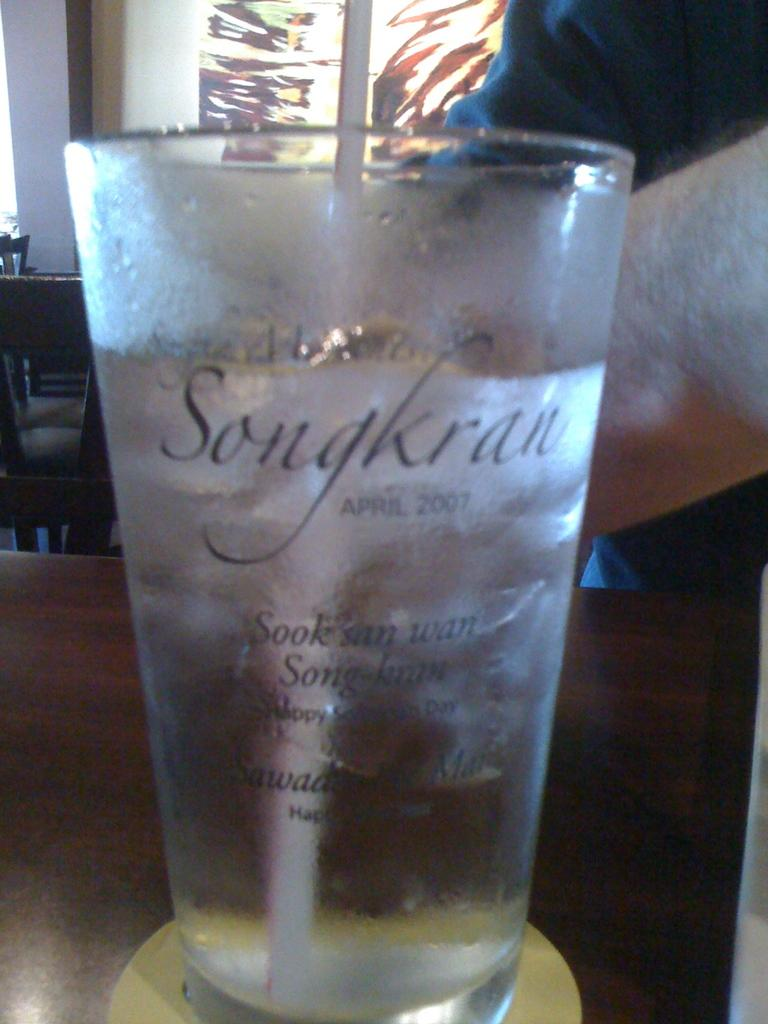<image>
Provide a brief description of the given image. the year 2007 is on the glass that has ice on it 